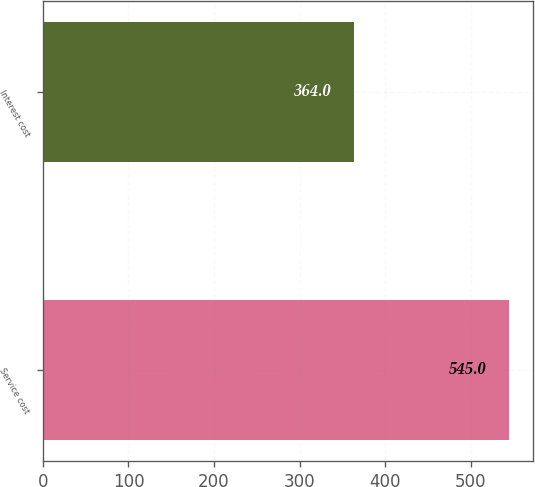Convert chart to OTSL. <chart><loc_0><loc_0><loc_500><loc_500><bar_chart><fcel>Service cost<fcel>Interest cost<nl><fcel>545<fcel>364<nl></chart> 